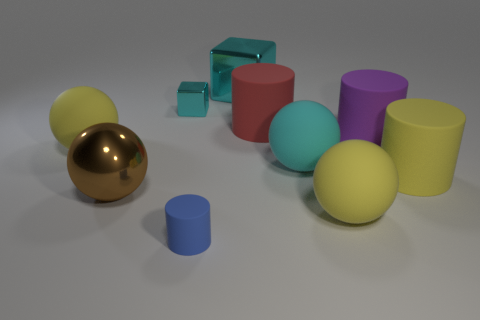There is a block to the left of the blue object; is it the same color as the large metal cube?
Ensure brevity in your answer.  Yes. There is a large block that is the same color as the small shiny thing; what is its material?
Your answer should be compact. Metal. There is a rubber ball that is the same color as the large metallic block; what size is it?
Keep it short and to the point. Large. Do the big matte cylinder in front of the big cyan rubber thing and the large rubber thing that is left of the large brown ball have the same color?
Keep it short and to the point. Yes. Are there any large rubber things of the same color as the tiny metallic block?
Give a very brief answer. Yes. Are there any other things of the same color as the tiny cylinder?
Ensure brevity in your answer.  No. What shape is the big brown thing?
Offer a very short reply. Sphere. What color is the tiny thing that is made of the same material as the yellow cylinder?
Make the answer very short. Blue. Are there more large rubber things than big objects?
Keep it short and to the point. No. Is there a yellow matte block?
Keep it short and to the point. No. 